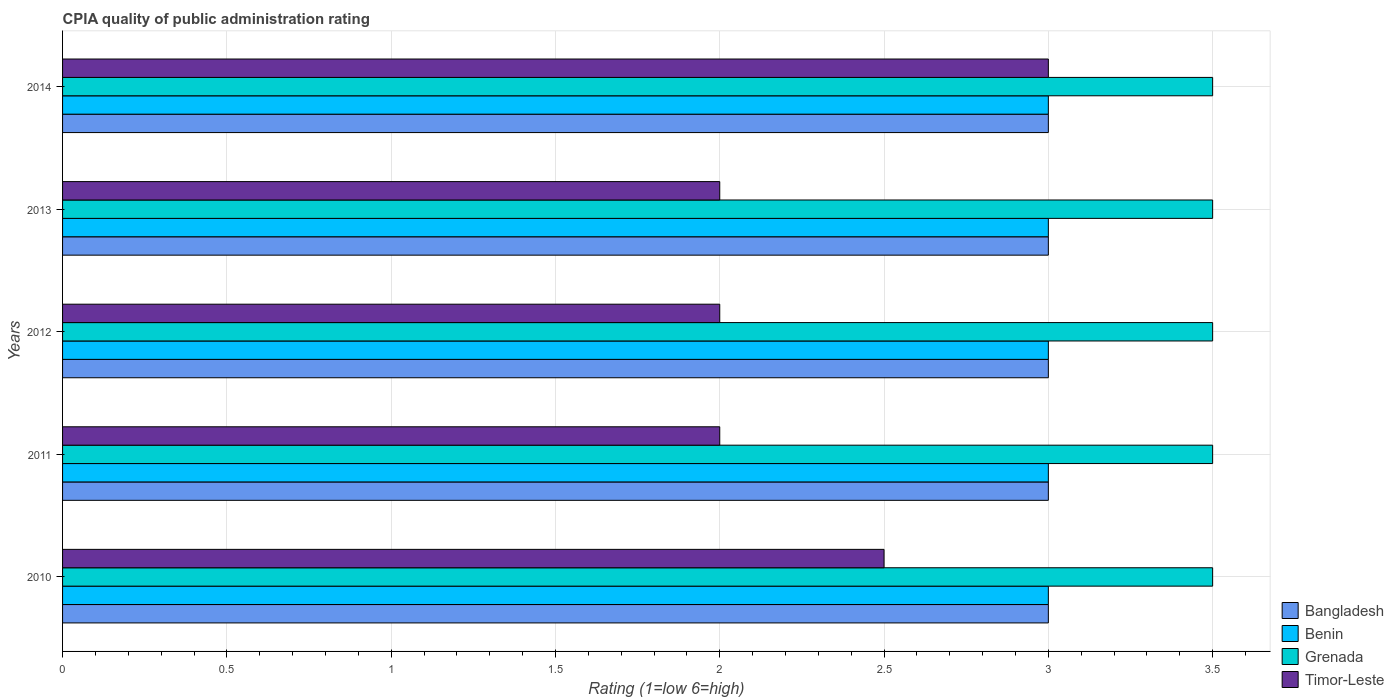How many different coloured bars are there?
Keep it short and to the point. 4. How many groups of bars are there?
Offer a very short reply. 5. Are the number of bars per tick equal to the number of legend labels?
Provide a succinct answer. Yes. How many bars are there on the 1st tick from the top?
Provide a short and direct response. 4. In how many cases, is the number of bars for a given year not equal to the number of legend labels?
Your answer should be compact. 0. What is the CPIA rating in Benin in 2014?
Keep it short and to the point. 3. Across all years, what is the minimum CPIA rating in Benin?
Your answer should be compact. 3. What is the total CPIA rating in Grenada in the graph?
Give a very brief answer. 17.5. What is the difference between the CPIA rating in Grenada in 2011 and that in 2014?
Make the answer very short. 0. What is the average CPIA rating in Bangladesh per year?
Offer a very short reply. 3. In how many years, is the CPIA rating in Timor-Leste greater than 3.3 ?
Offer a terse response. 0. Is the CPIA rating in Bangladesh in 2011 less than that in 2012?
Provide a succinct answer. No. Is the difference between the CPIA rating in Timor-Leste in 2011 and 2014 greater than the difference between the CPIA rating in Bangladesh in 2011 and 2014?
Provide a short and direct response. No. What is the difference between the highest and the second highest CPIA rating in Grenada?
Your response must be concise. 0. What is the difference between the highest and the lowest CPIA rating in Bangladesh?
Provide a succinct answer. 0. In how many years, is the CPIA rating in Grenada greater than the average CPIA rating in Grenada taken over all years?
Your response must be concise. 0. Is the sum of the CPIA rating in Timor-Leste in 2010 and 2012 greater than the maximum CPIA rating in Bangladesh across all years?
Ensure brevity in your answer.  Yes. Is it the case that in every year, the sum of the CPIA rating in Bangladesh and CPIA rating in Benin is greater than the sum of CPIA rating in Timor-Leste and CPIA rating in Grenada?
Make the answer very short. No. What does the 3rd bar from the top in 2014 represents?
Provide a short and direct response. Benin. What does the 4th bar from the bottom in 2014 represents?
Offer a very short reply. Timor-Leste. Is it the case that in every year, the sum of the CPIA rating in Benin and CPIA rating in Bangladesh is greater than the CPIA rating in Grenada?
Offer a terse response. Yes. How many bars are there?
Provide a succinct answer. 20. Are all the bars in the graph horizontal?
Provide a succinct answer. Yes. How many years are there in the graph?
Make the answer very short. 5. What is the difference between two consecutive major ticks on the X-axis?
Provide a succinct answer. 0.5. Where does the legend appear in the graph?
Provide a short and direct response. Bottom right. How many legend labels are there?
Ensure brevity in your answer.  4. What is the title of the graph?
Ensure brevity in your answer.  CPIA quality of public administration rating. Does "Congo (Democratic)" appear as one of the legend labels in the graph?
Offer a terse response. No. What is the Rating (1=low 6=high) of Grenada in 2010?
Give a very brief answer. 3.5. What is the Rating (1=low 6=high) in Grenada in 2012?
Provide a succinct answer. 3.5. What is the Rating (1=low 6=high) in Benin in 2013?
Your answer should be very brief. 3. What is the Rating (1=low 6=high) in Grenada in 2013?
Provide a succinct answer. 3.5. What is the Rating (1=low 6=high) in Bangladesh in 2014?
Your answer should be very brief. 3. What is the Rating (1=low 6=high) of Grenada in 2014?
Provide a short and direct response. 3.5. What is the Rating (1=low 6=high) in Timor-Leste in 2014?
Your answer should be very brief. 3. Across all years, what is the maximum Rating (1=low 6=high) of Benin?
Give a very brief answer. 3. Across all years, what is the maximum Rating (1=low 6=high) in Timor-Leste?
Provide a short and direct response. 3. Across all years, what is the minimum Rating (1=low 6=high) in Benin?
Offer a very short reply. 3. What is the total Rating (1=low 6=high) of Bangladesh in the graph?
Offer a very short reply. 15. What is the total Rating (1=low 6=high) of Grenada in the graph?
Give a very brief answer. 17.5. What is the total Rating (1=low 6=high) in Timor-Leste in the graph?
Offer a very short reply. 11.5. What is the difference between the Rating (1=low 6=high) of Bangladesh in 2010 and that in 2011?
Give a very brief answer. 0. What is the difference between the Rating (1=low 6=high) of Timor-Leste in 2010 and that in 2011?
Offer a terse response. 0.5. What is the difference between the Rating (1=low 6=high) in Grenada in 2010 and that in 2012?
Offer a very short reply. 0. What is the difference between the Rating (1=low 6=high) of Timor-Leste in 2010 and that in 2013?
Give a very brief answer. 0.5. What is the difference between the Rating (1=low 6=high) in Benin in 2010 and that in 2014?
Make the answer very short. 0. What is the difference between the Rating (1=low 6=high) of Timor-Leste in 2010 and that in 2014?
Offer a very short reply. -0.5. What is the difference between the Rating (1=low 6=high) in Bangladesh in 2011 and that in 2012?
Provide a short and direct response. 0. What is the difference between the Rating (1=low 6=high) of Bangladesh in 2011 and that in 2013?
Give a very brief answer. 0. What is the difference between the Rating (1=low 6=high) of Timor-Leste in 2011 and that in 2014?
Make the answer very short. -1. What is the difference between the Rating (1=low 6=high) in Bangladesh in 2012 and that in 2013?
Make the answer very short. 0. What is the difference between the Rating (1=low 6=high) of Grenada in 2012 and that in 2013?
Provide a succinct answer. 0. What is the difference between the Rating (1=low 6=high) of Grenada in 2012 and that in 2014?
Your answer should be very brief. 0. What is the difference between the Rating (1=low 6=high) of Bangladesh in 2013 and that in 2014?
Ensure brevity in your answer.  0. What is the difference between the Rating (1=low 6=high) in Benin in 2013 and that in 2014?
Your response must be concise. 0. What is the difference between the Rating (1=low 6=high) of Grenada in 2013 and that in 2014?
Provide a short and direct response. 0. What is the difference between the Rating (1=low 6=high) of Bangladesh in 2010 and the Rating (1=low 6=high) of Timor-Leste in 2011?
Ensure brevity in your answer.  1. What is the difference between the Rating (1=low 6=high) of Benin in 2010 and the Rating (1=low 6=high) of Grenada in 2011?
Your answer should be compact. -0.5. What is the difference between the Rating (1=low 6=high) of Benin in 2010 and the Rating (1=low 6=high) of Timor-Leste in 2011?
Ensure brevity in your answer.  1. What is the difference between the Rating (1=low 6=high) in Bangladesh in 2010 and the Rating (1=low 6=high) in Benin in 2012?
Your answer should be very brief. 0. What is the difference between the Rating (1=low 6=high) in Benin in 2010 and the Rating (1=low 6=high) in Grenada in 2012?
Give a very brief answer. -0.5. What is the difference between the Rating (1=low 6=high) in Grenada in 2010 and the Rating (1=low 6=high) in Timor-Leste in 2012?
Keep it short and to the point. 1.5. What is the difference between the Rating (1=low 6=high) of Bangladesh in 2010 and the Rating (1=low 6=high) of Benin in 2013?
Offer a very short reply. 0. What is the difference between the Rating (1=low 6=high) of Bangladesh in 2010 and the Rating (1=low 6=high) of Grenada in 2013?
Your answer should be very brief. -0.5. What is the difference between the Rating (1=low 6=high) of Bangladesh in 2010 and the Rating (1=low 6=high) of Benin in 2014?
Your response must be concise. 0. What is the difference between the Rating (1=low 6=high) in Bangladesh in 2010 and the Rating (1=low 6=high) in Grenada in 2014?
Your answer should be compact. -0.5. What is the difference between the Rating (1=low 6=high) in Bangladesh in 2010 and the Rating (1=low 6=high) in Timor-Leste in 2014?
Keep it short and to the point. 0. What is the difference between the Rating (1=low 6=high) of Benin in 2010 and the Rating (1=low 6=high) of Grenada in 2014?
Offer a very short reply. -0.5. What is the difference between the Rating (1=low 6=high) in Grenada in 2010 and the Rating (1=low 6=high) in Timor-Leste in 2014?
Offer a very short reply. 0.5. What is the difference between the Rating (1=low 6=high) in Bangladesh in 2011 and the Rating (1=low 6=high) in Benin in 2012?
Provide a short and direct response. 0. What is the difference between the Rating (1=low 6=high) of Benin in 2011 and the Rating (1=low 6=high) of Grenada in 2012?
Offer a terse response. -0.5. What is the difference between the Rating (1=low 6=high) in Grenada in 2011 and the Rating (1=low 6=high) in Timor-Leste in 2012?
Offer a terse response. 1.5. What is the difference between the Rating (1=low 6=high) of Bangladesh in 2011 and the Rating (1=low 6=high) of Benin in 2013?
Your response must be concise. 0. What is the difference between the Rating (1=low 6=high) in Benin in 2011 and the Rating (1=low 6=high) in Grenada in 2013?
Offer a terse response. -0.5. What is the difference between the Rating (1=low 6=high) of Benin in 2011 and the Rating (1=low 6=high) of Timor-Leste in 2013?
Offer a terse response. 1. What is the difference between the Rating (1=low 6=high) of Bangladesh in 2011 and the Rating (1=low 6=high) of Grenada in 2014?
Ensure brevity in your answer.  -0.5. What is the difference between the Rating (1=low 6=high) in Bangladesh in 2011 and the Rating (1=low 6=high) in Timor-Leste in 2014?
Give a very brief answer. 0. What is the difference between the Rating (1=low 6=high) of Benin in 2011 and the Rating (1=low 6=high) of Grenada in 2014?
Ensure brevity in your answer.  -0.5. What is the difference between the Rating (1=low 6=high) in Bangladesh in 2012 and the Rating (1=low 6=high) in Benin in 2013?
Your answer should be very brief. 0. What is the difference between the Rating (1=low 6=high) in Benin in 2012 and the Rating (1=low 6=high) in Timor-Leste in 2013?
Ensure brevity in your answer.  1. What is the difference between the Rating (1=low 6=high) in Grenada in 2012 and the Rating (1=low 6=high) in Timor-Leste in 2013?
Keep it short and to the point. 1.5. What is the difference between the Rating (1=low 6=high) of Bangladesh in 2012 and the Rating (1=low 6=high) of Benin in 2014?
Offer a terse response. 0. What is the difference between the Rating (1=low 6=high) of Bangladesh in 2012 and the Rating (1=low 6=high) of Timor-Leste in 2014?
Offer a terse response. 0. What is the difference between the Rating (1=low 6=high) in Benin in 2012 and the Rating (1=low 6=high) in Timor-Leste in 2014?
Provide a short and direct response. 0. What is the difference between the Rating (1=low 6=high) of Grenada in 2012 and the Rating (1=low 6=high) of Timor-Leste in 2014?
Offer a terse response. 0.5. What is the difference between the Rating (1=low 6=high) of Bangladesh in 2013 and the Rating (1=low 6=high) of Grenada in 2014?
Provide a succinct answer. -0.5. What is the difference between the Rating (1=low 6=high) of Benin in 2013 and the Rating (1=low 6=high) of Grenada in 2014?
Provide a succinct answer. -0.5. What is the difference between the Rating (1=low 6=high) in Grenada in 2013 and the Rating (1=low 6=high) in Timor-Leste in 2014?
Give a very brief answer. 0.5. What is the average Rating (1=low 6=high) of Benin per year?
Offer a very short reply. 3. In the year 2010, what is the difference between the Rating (1=low 6=high) in Bangladesh and Rating (1=low 6=high) in Benin?
Provide a short and direct response. 0. In the year 2010, what is the difference between the Rating (1=low 6=high) in Bangladesh and Rating (1=low 6=high) in Grenada?
Make the answer very short. -0.5. In the year 2011, what is the difference between the Rating (1=low 6=high) of Bangladesh and Rating (1=low 6=high) of Benin?
Your answer should be very brief. 0. In the year 2011, what is the difference between the Rating (1=low 6=high) in Bangladesh and Rating (1=low 6=high) in Grenada?
Offer a very short reply. -0.5. In the year 2011, what is the difference between the Rating (1=low 6=high) in Benin and Rating (1=low 6=high) in Timor-Leste?
Provide a short and direct response. 1. In the year 2011, what is the difference between the Rating (1=low 6=high) of Grenada and Rating (1=low 6=high) of Timor-Leste?
Ensure brevity in your answer.  1.5. In the year 2012, what is the difference between the Rating (1=low 6=high) of Bangladesh and Rating (1=low 6=high) of Grenada?
Provide a succinct answer. -0.5. In the year 2012, what is the difference between the Rating (1=low 6=high) in Bangladesh and Rating (1=low 6=high) in Timor-Leste?
Provide a short and direct response. 1. In the year 2012, what is the difference between the Rating (1=low 6=high) in Benin and Rating (1=low 6=high) in Grenada?
Provide a short and direct response. -0.5. In the year 2012, what is the difference between the Rating (1=low 6=high) in Benin and Rating (1=low 6=high) in Timor-Leste?
Offer a very short reply. 1. In the year 2012, what is the difference between the Rating (1=low 6=high) in Grenada and Rating (1=low 6=high) in Timor-Leste?
Offer a terse response. 1.5. In the year 2013, what is the difference between the Rating (1=low 6=high) in Grenada and Rating (1=low 6=high) in Timor-Leste?
Provide a succinct answer. 1.5. In the year 2014, what is the difference between the Rating (1=low 6=high) of Bangladesh and Rating (1=low 6=high) of Benin?
Your response must be concise. 0. In the year 2014, what is the difference between the Rating (1=low 6=high) in Bangladesh and Rating (1=low 6=high) in Timor-Leste?
Offer a terse response. 0. In the year 2014, what is the difference between the Rating (1=low 6=high) in Grenada and Rating (1=low 6=high) in Timor-Leste?
Offer a terse response. 0.5. What is the ratio of the Rating (1=low 6=high) of Timor-Leste in 2010 to that in 2011?
Provide a short and direct response. 1.25. What is the ratio of the Rating (1=low 6=high) in Bangladesh in 2010 to that in 2012?
Ensure brevity in your answer.  1. What is the ratio of the Rating (1=low 6=high) in Grenada in 2010 to that in 2012?
Keep it short and to the point. 1. What is the ratio of the Rating (1=low 6=high) of Timor-Leste in 2010 to that in 2012?
Ensure brevity in your answer.  1.25. What is the ratio of the Rating (1=low 6=high) of Bangladesh in 2010 to that in 2013?
Your answer should be compact. 1. What is the ratio of the Rating (1=low 6=high) in Grenada in 2010 to that in 2014?
Provide a succinct answer. 1. What is the ratio of the Rating (1=low 6=high) in Timor-Leste in 2010 to that in 2014?
Ensure brevity in your answer.  0.83. What is the ratio of the Rating (1=low 6=high) in Bangladesh in 2011 to that in 2012?
Offer a terse response. 1. What is the ratio of the Rating (1=low 6=high) of Benin in 2011 to that in 2012?
Your response must be concise. 1. What is the ratio of the Rating (1=low 6=high) of Grenada in 2011 to that in 2012?
Offer a terse response. 1. What is the ratio of the Rating (1=low 6=high) in Bangladesh in 2011 to that in 2013?
Offer a terse response. 1. What is the ratio of the Rating (1=low 6=high) of Grenada in 2011 to that in 2013?
Make the answer very short. 1. What is the ratio of the Rating (1=low 6=high) in Timor-Leste in 2011 to that in 2013?
Provide a succinct answer. 1. What is the ratio of the Rating (1=low 6=high) in Grenada in 2012 to that in 2013?
Give a very brief answer. 1. What is the ratio of the Rating (1=low 6=high) of Timor-Leste in 2012 to that in 2013?
Provide a short and direct response. 1. What is the ratio of the Rating (1=low 6=high) of Bangladesh in 2012 to that in 2014?
Your response must be concise. 1. What is the ratio of the Rating (1=low 6=high) in Bangladesh in 2013 to that in 2014?
Your answer should be compact. 1. What is the ratio of the Rating (1=low 6=high) of Benin in 2013 to that in 2014?
Provide a short and direct response. 1. What is the difference between the highest and the second highest Rating (1=low 6=high) in Bangladesh?
Offer a very short reply. 0. What is the difference between the highest and the second highest Rating (1=low 6=high) in Timor-Leste?
Give a very brief answer. 0.5. What is the difference between the highest and the lowest Rating (1=low 6=high) of Grenada?
Make the answer very short. 0. 